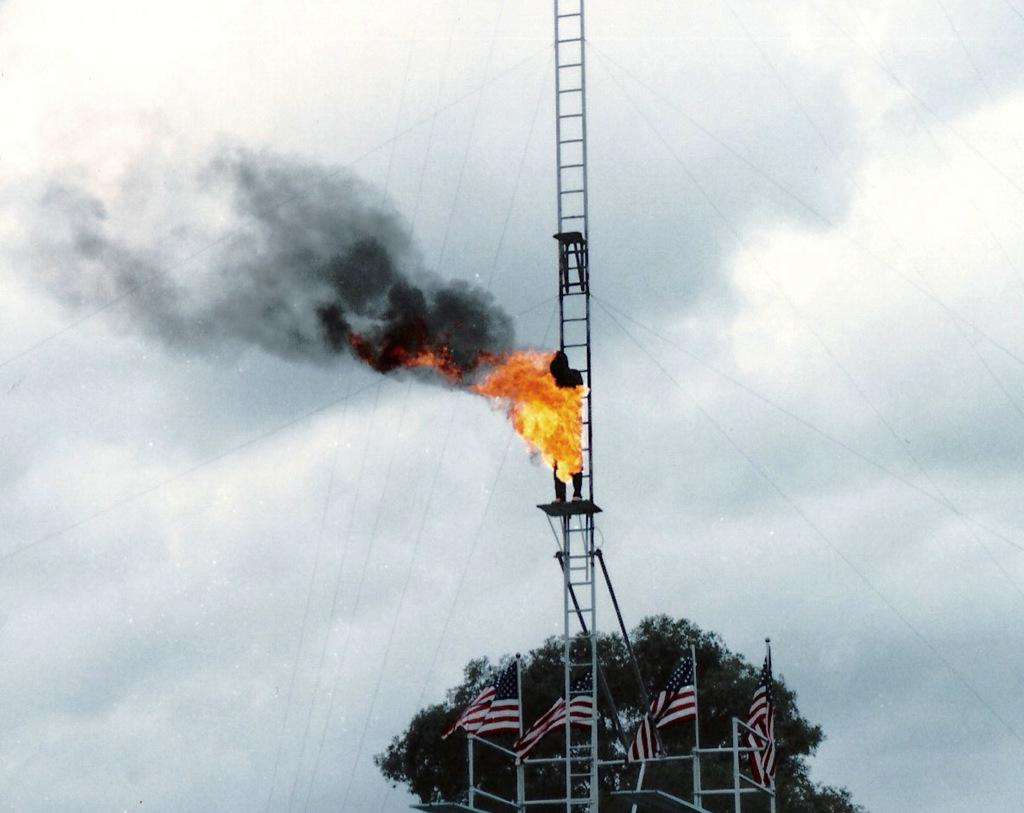What can be seen in the image that represents a symbol or country? There are flags in the image. What type of natural elements can be seen in the image? There are leaves in the image. What type of structural elements can be seen in the image? There are rods and a ladder in the image. Can you describe the person in the image? There is a person in the image. What is the source of heat or light in the image? There is fire in the image. What other objects can be seen in the image? There are some objects in the image. What can be seen in the background of the image? The sky is visible in the background of the image, and there are clouds in the sky. What type of print can be seen on the base of the branch in the image? There is no base or branch present in the image. How many branches are visible in the image? There are no branches visible in the image. 